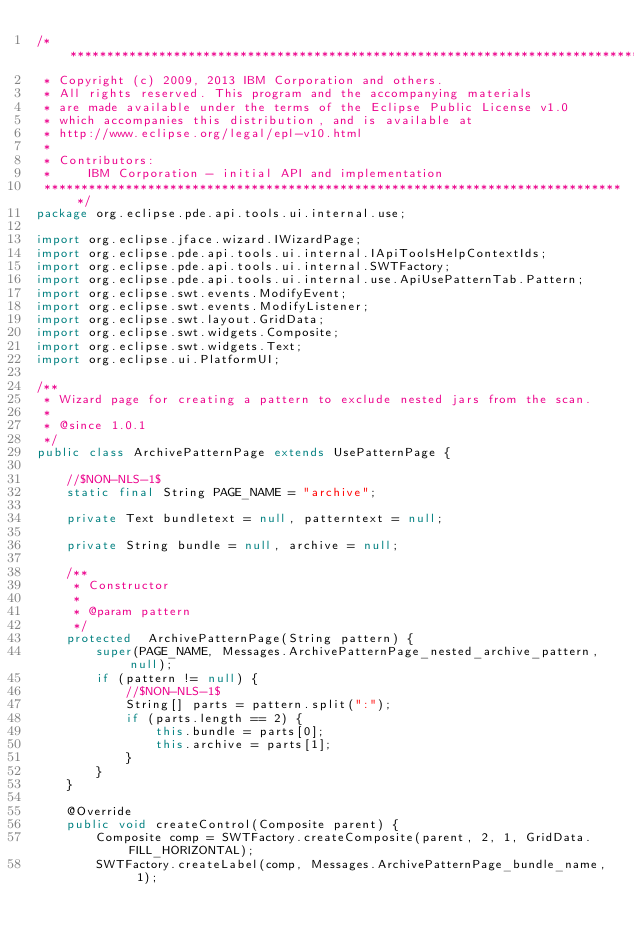Convert code to text. <code><loc_0><loc_0><loc_500><loc_500><_Java_>/*******************************************************************************
 * Copyright (c) 2009, 2013 IBM Corporation and others.
 * All rights reserved. This program and the accompanying materials
 * are made available under the terms of the Eclipse Public License v1.0
 * which accompanies this distribution, and is available at
 * http://www.eclipse.org/legal/epl-v10.html
 *
 * Contributors:
 *     IBM Corporation - initial API and implementation
 *******************************************************************************/
package org.eclipse.pde.api.tools.ui.internal.use;

import org.eclipse.jface.wizard.IWizardPage;
import org.eclipse.pde.api.tools.ui.internal.IApiToolsHelpContextIds;
import org.eclipse.pde.api.tools.ui.internal.SWTFactory;
import org.eclipse.pde.api.tools.ui.internal.use.ApiUsePatternTab.Pattern;
import org.eclipse.swt.events.ModifyEvent;
import org.eclipse.swt.events.ModifyListener;
import org.eclipse.swt.layout.GridData;
import org.eclipse.swt.widgets.Composite;
import org.eclipse.swt.widgets.Text;
import org.eclipse.ui.PlatformUI;

/**
 * Wizard page for creating a pattern to exclude nested jars from the scan.
 *
 * @since 1.0.1
 */
public class ArchivePatternPage extends UsePatternPage {

    //$NON-NLS-1$
    static final String PAGE_NAME = "archive";

    private Text bundletext = null, patterntext = null;

    private String bundle = null, archive = null;

    /**
	 * Constructor
	 *
	 * @param pattern
	 */
    protected  ArchivePatternPage(String pattern) {
        super(PAGE_NAME, Messages.ArchivePatternPage_nested_archive_pattern, null);
        if (pattern != null) {
            //$NON-NLS-1$
            String[] parts = pattern.split(":");
            if (parts.length == 2) {
                this.bundle = parts[0];
                this.archive = parts[1];
            }
        }
    }

    @Override
    public void createControl(Composite parent) {
        Composite comp = SWTFactory.createComposite(parent, 2, 1, GridData.FILL_HORIZONTAL);
        SWTFactory.createLabel(comp, Messages.ArchivePatternPage_bundle_name, 1);</code> 